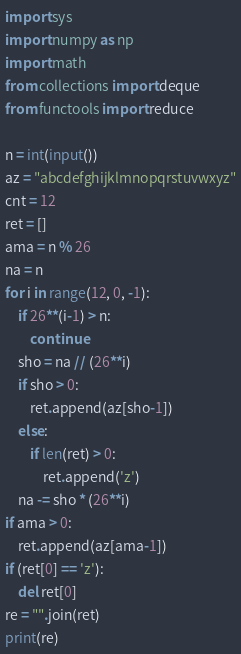Convert code to text. <code><loc_0><loc_0><loc_500><loc_500><_Python_>import sys
import numpy as np
import math
from collections import deque 
from functools import reduce

n = int(input())
az = "abcdefghijklmnopqrstuvwxyz"
cnt = 12
ret = []
ama = n % 26
na = n
for i in range(12, 0, -1):
    if 26**(i-1) > n:
        continue
    sho = na // (26**i)
    if sho > 0:
        ret.append(az[sho-1])
    else:
        if len(ret) > 0:
            ret.append('z')
    na -= sho * (26**i)
if ama > 0:
    ret.append(az[ama-1])
if (ret[0] == 'z'):
    del ret[0]
re = "".join(ret)
print(re)

</code> 